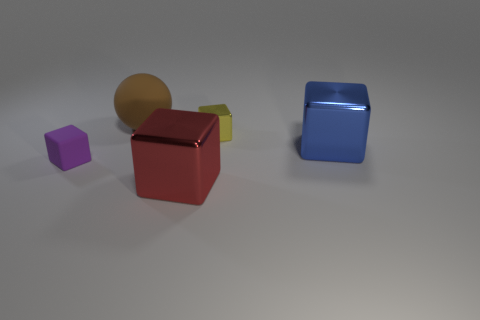Is there another tiny shiny thing that has the same shape as the red metal object? Yes, there is a blue metal object in the image that has the same cube shape as the red one, radiating with a similar glossy finish. 